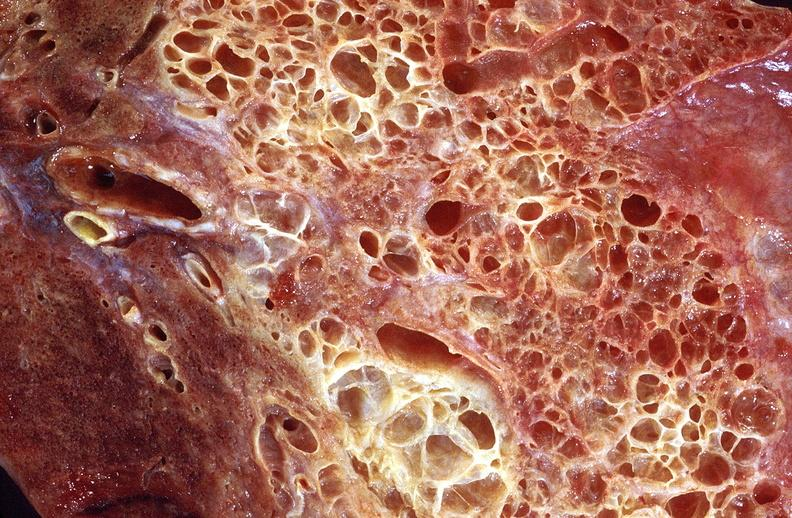where is this?
Answer the question using a single word or phrase. Lung 